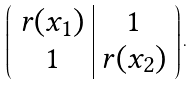<formula> <loc_0><loc_0><loc_500><loc_500>\left ( \begin{array} { c | c } r ( x _ { 1 } ) & 1 \\ 1 & r ( x _ { 2 } ) \end{array} \right ) .</formula> 